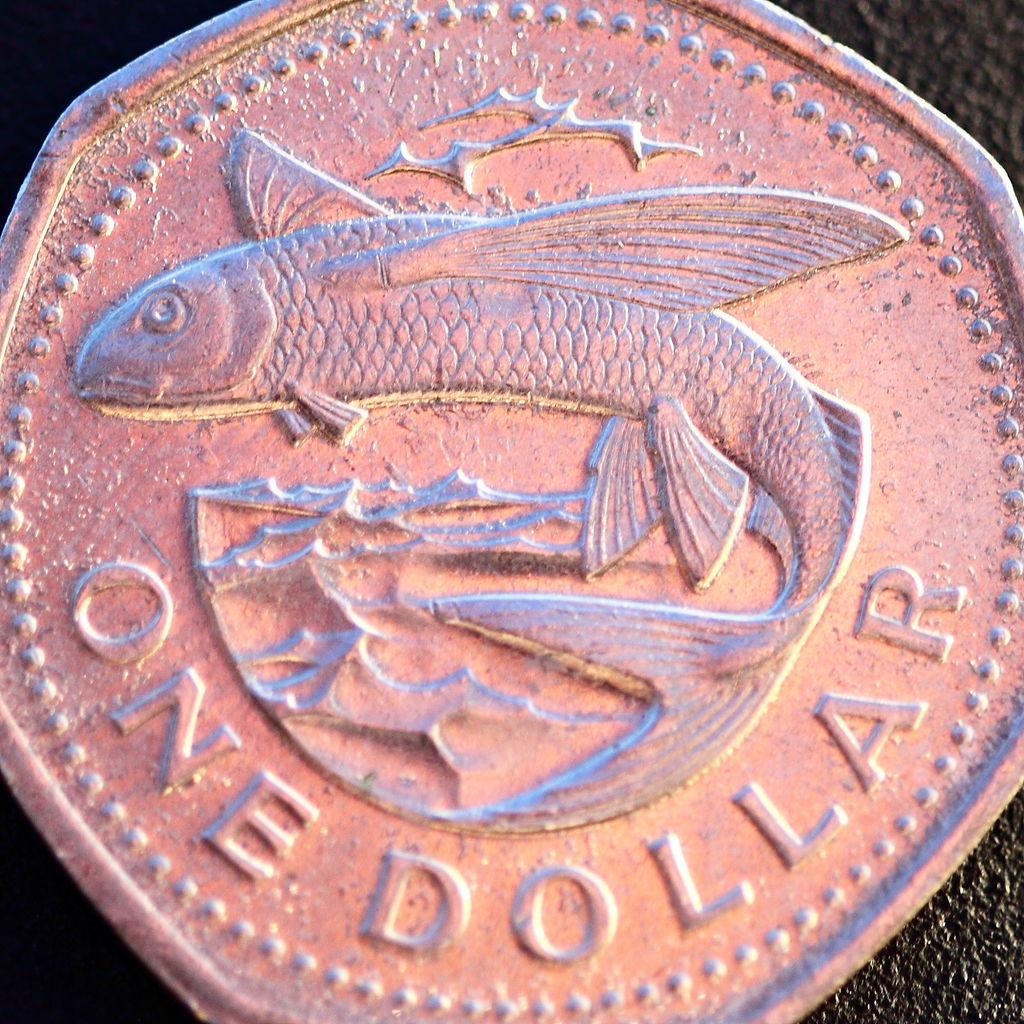<image>
Offer a succinct explanation of the picture presented. A coin with a fish on it is worth one dollar. 